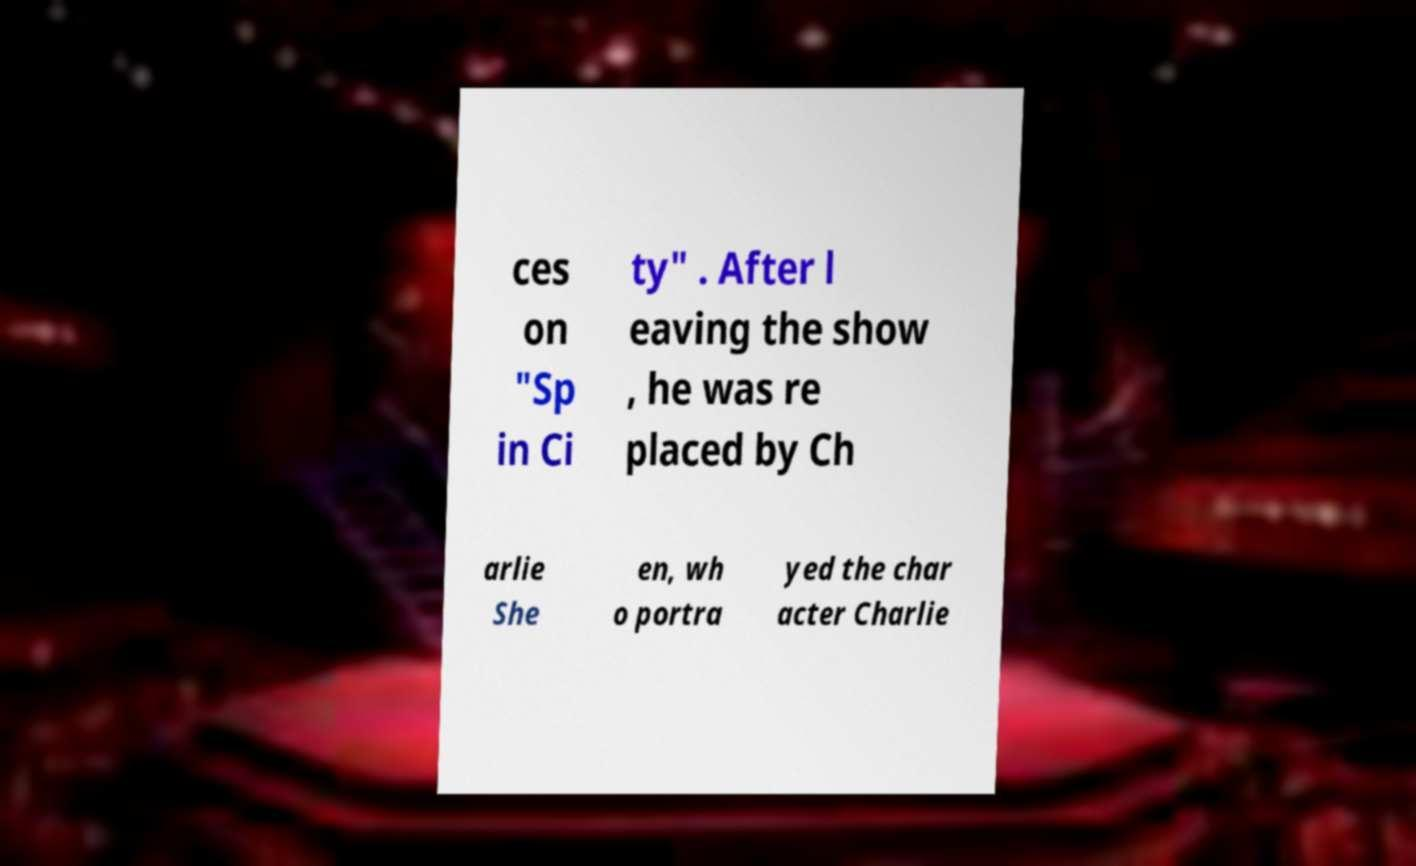Could you extract and type out the text from this image? ces on "Sp in Ci ty" . After l eaving the show , he was re placed by Ch arlie She en, wh o portra yed the char acter Charlie 